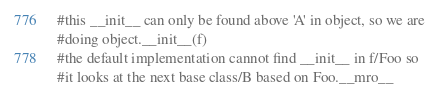<code> <loc_0><loc_0><loc_500><loc_500><_Python_>#this __init__ can only be found above 'A' in object, so we are
#doing object.__init__(f)
#the default implementation cannot find __init__ in f/Foo so 
#it looks at the next base class/B based on Foo.__mro__
</code> 